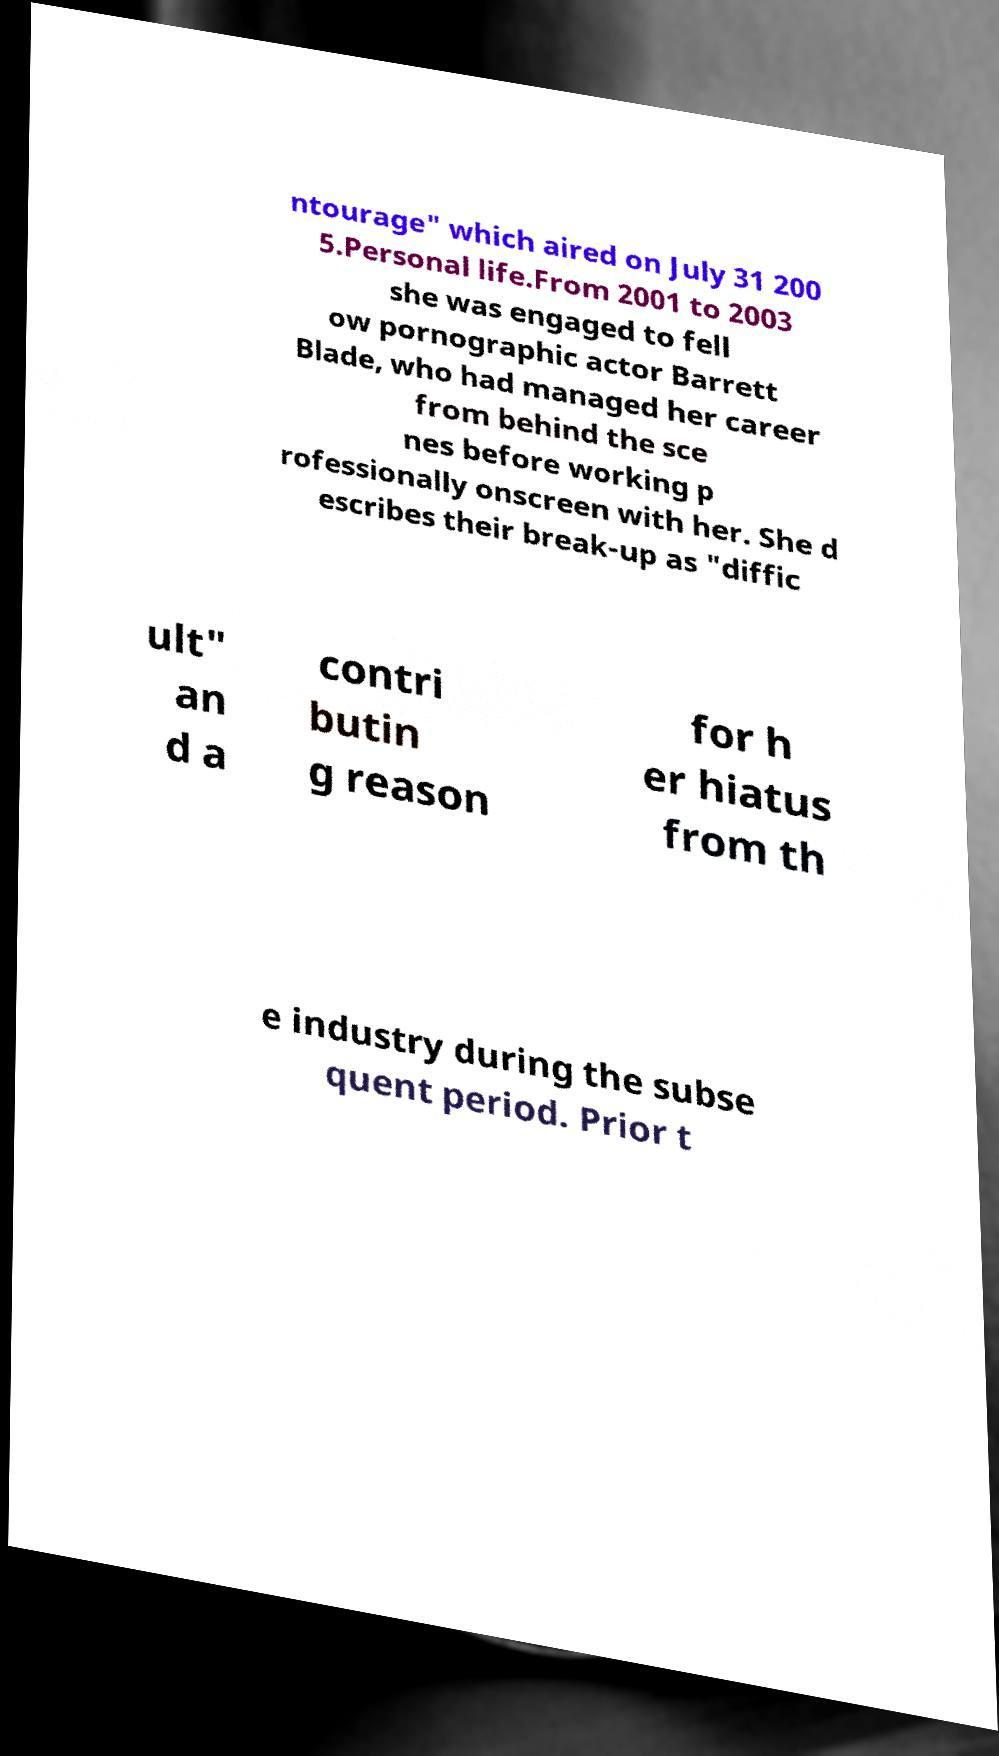Please read and relay the text visible in this image. What does it say? ntourage" which aired on July 31 200 5.Personal life.From 2001 to 2003 she was engaged to fell ow pornographic actor Barrett Blade, who had managed her career from behind the sce nes before working p rofessionally onscreen with her. She d escribes their break-up as "diffic ult" an d a contri butin g reason for h er hiatus from th e industry during the subse quent period. Prior t 